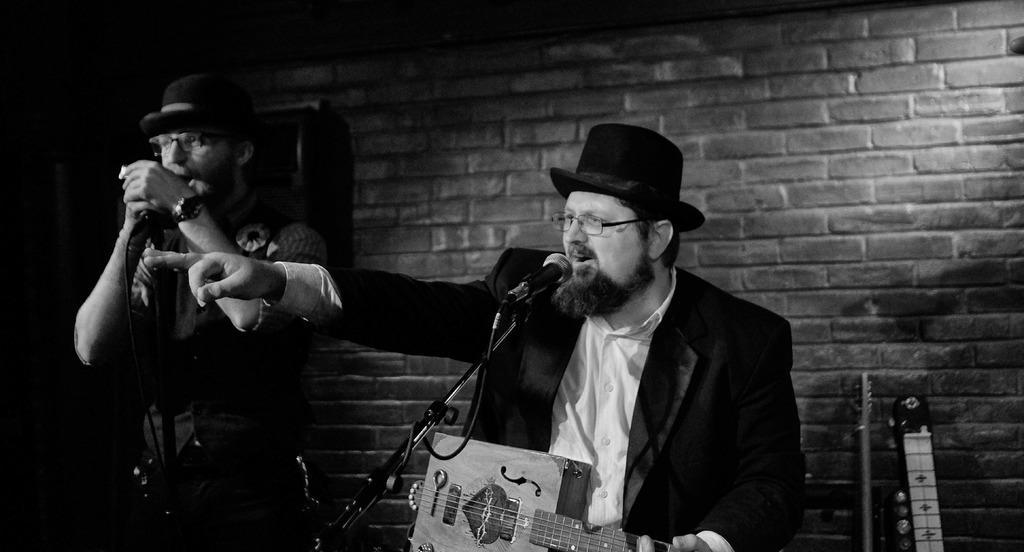Could you give a brief overview of what you see in this image? This is a picture of two people wearing black suits and hat on them and have spectacles and some mustache and one among them is holding the mike and the other is holding a musical instrument playing in front of a mike and behind them there is a small brick wall which is dark in color. 